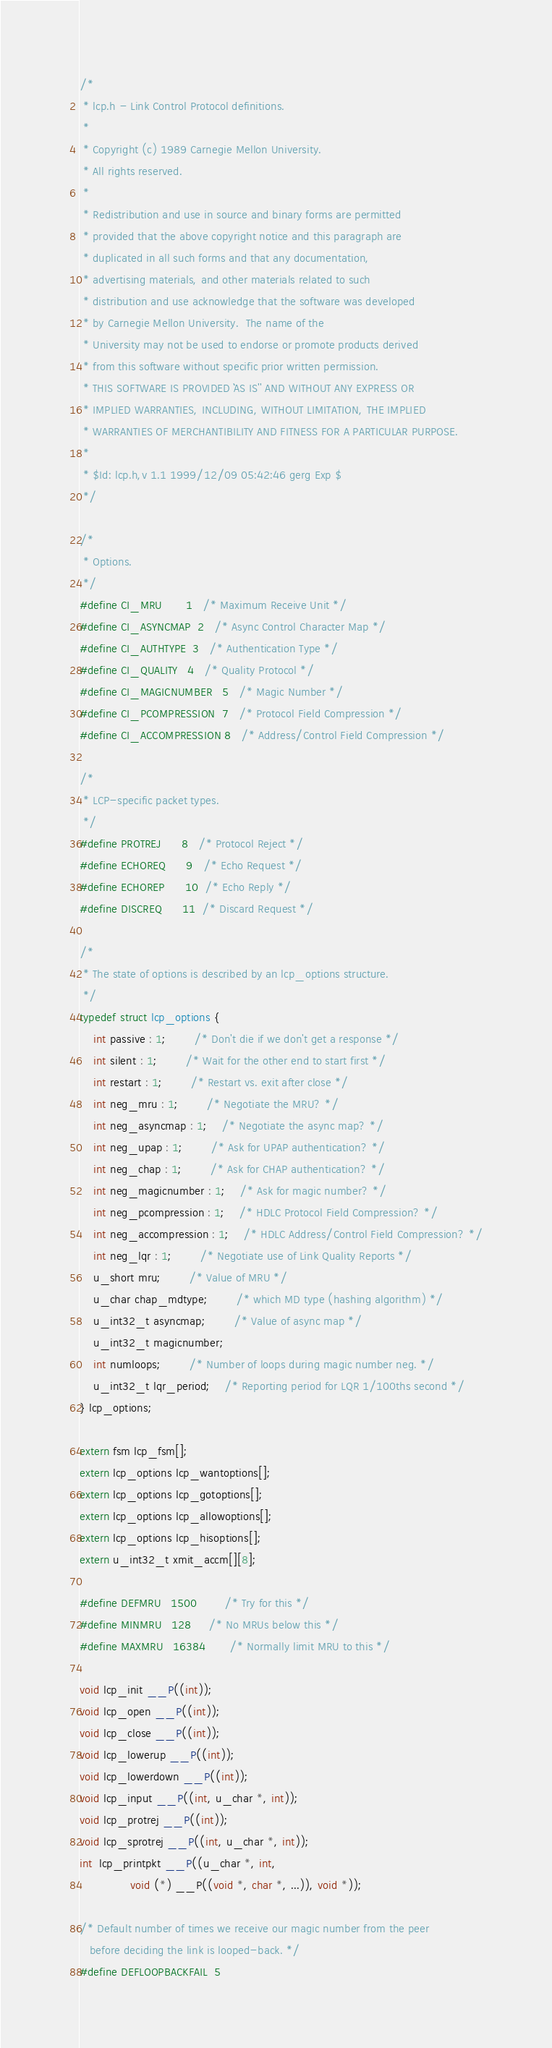Convert code to text. <code><loc_0><loc_0><loc_500><loc_500><_C_>/*
 * lcp.h - Link Control Protocol definitions.
 *
 * Copyright (c) 1989 Carnegie Mellon University.
 * All rights reserved.
 *
 * Redistribution and use in source and binary forms are permitted
 * provided that the above copyright notice and this paragraph are
 * duplicated in all such forms and that any documentation,
 * advertising materials, and other materials related to such
 * distribution and use acknowledge that the software was developed
 * by Carnegie Mellon University.  The name of the
 * University may not be used to endorse or promote products derived
 * from this software without specific prior written permission.
 * THIS SOFTWARE IS PROVIDED ``AS IS'' AND WITHOUT ANY EXPRESS OR
 * IMPLIED WARRANTIES, INCLUDING, WITHOUT LIMITATION, THE IMPLIED
 * WARRANTIES OF MERCHANTIBILITY AND FITNESS FOR A PARTICULAR PURPOSE.
 *
 * $Id: lcp.h,v 1.1 1999/12/09 05:42:46 gerg Exp $
 */

/*
 * Options.
 */
#define CI_MRU		1	/* Maximum Receive Unit */
#define CI_ASYNCMAP	2	/* Async Control Character Map */
#define CI_AUTHTYPE	3	/* Authentication Type */
#define CI_QUALITY	4	/* Quality Protocol */
#define CI_MAGICNUMBER	5	/* Magic Number */
#define CI_PCOMPRESSION	7	/* Protocol Field Compression */
#define CI_ACCOMPRESSION 8	/* Address/Control Field Compression */

/*
 * LCP-specific packet types.
 */
#define PROTREJ		8	/* Protocol Reject */
#define ECHOREQ		9	/* Echo Request */
#define ECHOREP		10	/* Echo Reply */
#define DISCREQ		11	/* Discard Request */

/*
 * The state of options is described by an lcp_options structure.
 */
typedef struct lcp_options {
    int passive : 1;		/* Don't die if we don't get a response */
    int silent : 1;		/* Wait for the other end to start first */
    int restart : 1;		/* Restart vs. exit after close */
    int neg_mru : 1;		/* Negotiate the MRU? */
    int neg_asyncmap : 1;	/* Negotiate the async map? */
    int neg_upap : 1;		/* Ask for UPAP authentication? */
    int neg_chap : 1;		/* Ask for CHAP authentication? */
    int neg_magicnumber : 1;	/* Ask for magic number? */
    int neg_pcompression : 1;	/* HDLC Protocol Field Compression? */
    int neg_accompression : 1;	/* HDLC Address/Control Field Compression? */
    int neg_lqr : 1;		/* Negotiate use of Link Quality Reports */
    u_short mru;		/* Value of MRU */
    u_char chap_mdtype;		/* which MD type (hashing algorithm) */
    u_int32_t asyncmap;		/* Value of async map */
    u_int32_t magicnumber;
    int numloops;		/* Number of loops during magic number neg. */
    u_int32_t lqr_period;	/* Reporting period for LQR 1/100ths second */
} lcp_options;

extern fsm lcp_fsm[];
extern lcp_options lcp_wantoptions[];
extern lcp_options lcp_gotoptions[];
extern lcp_options lcp_allowoptions[];
extern lcp_options lcp_hisoptions[];
extern u_int32_t xmit_accm[][8];

#define DEFMRU	1500		/* Try for this */
#define MINMRU	128		/* No MRUs below this */
#define MAXMRU	16384		/* Normally limit MRU to this */

void lcp_init __P((int));
void lcp_open __P((int));
void lcp_close __P((int));
void lcp_lowerup __P((int));
void lcp_lowerdown __P((int));
void lcp_input __P((int, u_char *, int));
void lcp_protrej __P((int));
void lcp_sprotrej __P((int, u_char *, int));
int  lcp_printpkt __P((u_char *, int,
		       void (*) __P((void *, char *, ...)), void *));

/* Default number of times we receive our magic number from the peer
   before deciding the link is looped-back. */
#define DEFLOOPBACKFAIL	5
</code> 